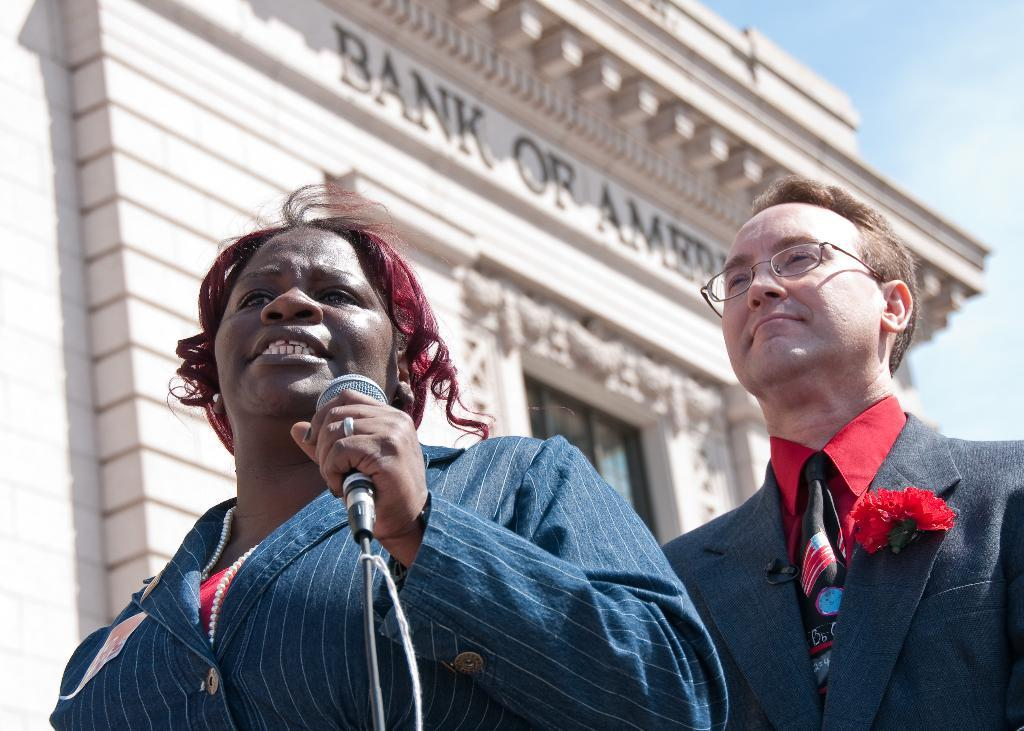Who is the main subject in the image? There is a lady in the image. What is the lady holding in the image? The lady is holding a mic. Who else is present in the image? There is a man in the image. How is the man positioned in relation to the lady? The man is standing behind the lady. What can be seen in the background of the image? They are standing in front of a Bank of Baroda building. What is the distance between the lady and the afterthought in the image? There is no afterthought present in the image, so it is not possible to determine the distance between the lady and an afterthought. 